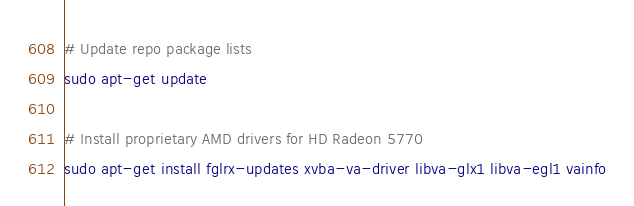Convert code to text. <code><loc_0><loc_0><loc_500><loc_500><_Bash_>
# Update repo package lists
sudo apt-get update

# Install proprietary AMD drivers for HD Radeon 5770
sudo apt-get install fglrx-updates xvba-va-driver libva-glx1 libva-egl1 vainfo
</code> 